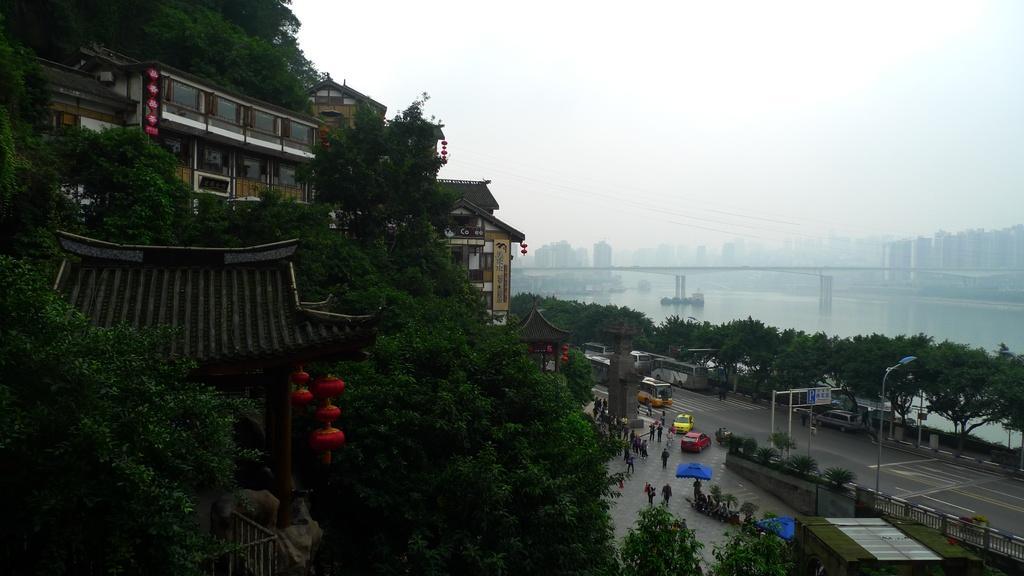Please provide a concise description of this image. There are vehicles on the road. Here we can see plants, trees, poles, boards, and buildings. There are persons on the road. This is water. In the background there is sky. 